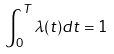<formula> <loc_0><loc_0><loc_500><loc_500>\int _ { 0 } ^ { T } \lambda ( t ) d t = 1</formula> 